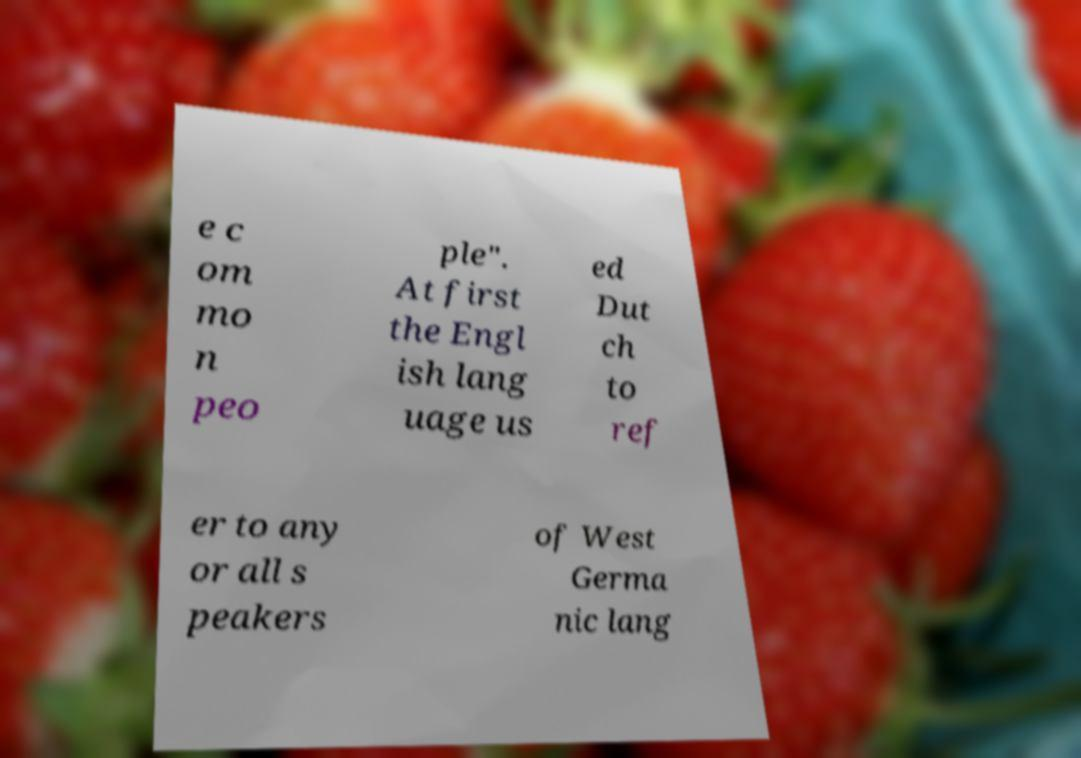Please identify and transcribe the text found in this image. e c om mo n peo ple". At first the Engl ish lang uage us ed Dut ch to ref er to any or all s peakers of West Germa nic lang 